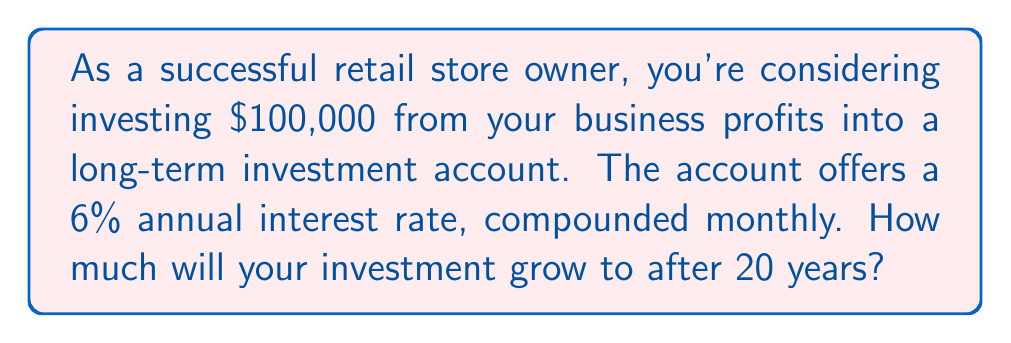What is the answer to this math problem? To solve this problem, we'll use the compound interest formula:

$$A = P(1 + \frac{r}{n})^{nt}$$

Where:
$A$ = Final amount
$P$ = Principal (initial investment)
$r$ = Annual interest rate (as a decimal)
$n$ = Number of times interest is compounded per year
$t$ = Number of years

Given:
$P = \$100,000$
$r = 0.06$ (6% expressed as a decimal)
$n = 12$ (compounded monthly)
$t = 20$ years

Let's substitute these values into the formula:

$$A = 100,000(1 + \frac{0.06}{12})^{12 \times 20}$$

$$A = 100,000(1 + 0.005)^{240}$$

$$A = 100,000(1.005)^{240}$$

Using a calculator to evaluate this expression:

$$A = 100,000 \times 3.310427$$

$$A = 331,042.70$$

Therefore, after 20 years, the investment will grow to $331,042.70.
Answer: $331,042.70 